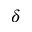Convert formula to latex. <formula><loc_0><loc_0><loc_500><loc_500>\delta</formula> 